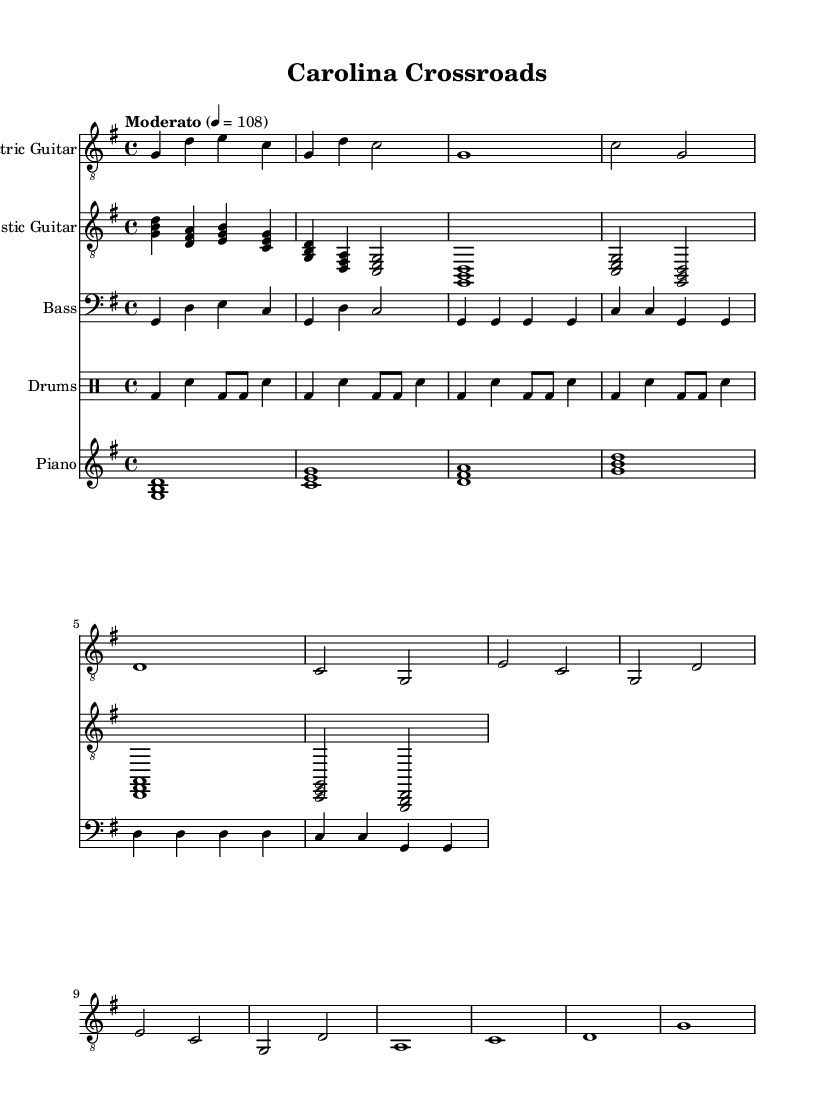What is the key signature of this music? The key signature is G major, which has one sharp (F#). This can be determined by looking at the first measure where the key signature is indicated.
Answer: G major What is the time signature of this music? The time signature is 4/4, which means there are four beats in each measure and the quarter note gets one beat. This can be seen at the beginning of the score right after the key signature.
Answer: 4/4 What is the tempo marking for this piece? The tempo marking is "Moderato" at a speed of 108 BPM. This information is located at the beginning of the score indicating the desired pace of the music.
Answer: Moderato, 108 Which instrument plays the intro of the piece? The electric guitar plays the intro, indicated by the first part written in the score labeled as "Electric Guitar." The specific notes under this part at the start confirm this.
Answer: Electric Guitar How many measures are in the Verse section of the music? The Verse section contains 4 measures. This can be verified by counting the measures in the part labeled as "Verse" within the electric guitar section.
Answer: 4 What type of beat pattern is used in the drums part? The drum part uses a basic rock beat pattern. This can be inferred from the repeating structure and the use of bass and snare drums in the drum notation.
Answer: Basic rock beat What chord is played during the Chorus section? The chords in the Chorus section are E, C, G, and D. These are shown in the acoustic guitar part of the score and align with the notes in the Chorus section.
Answer: E, C, G, D 